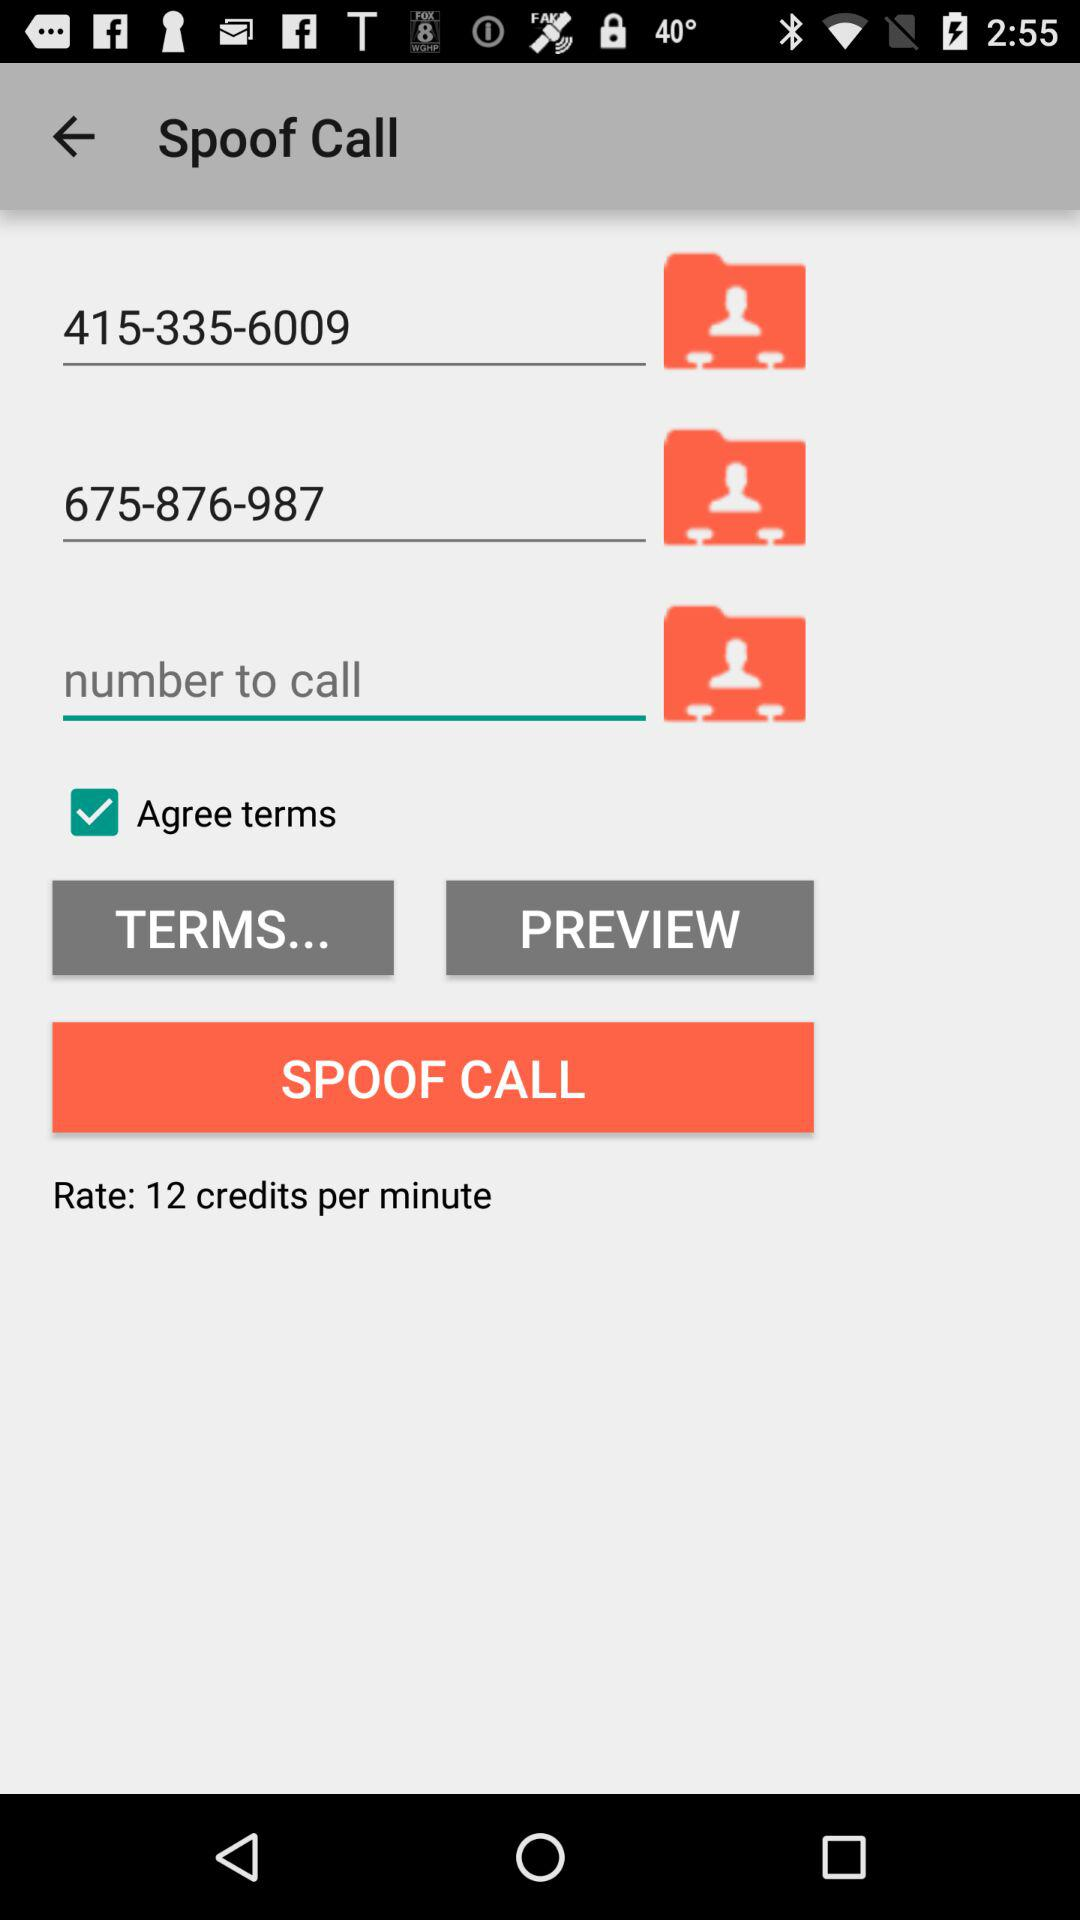What is the name of the application? The name of the application is "Spoof Call". 